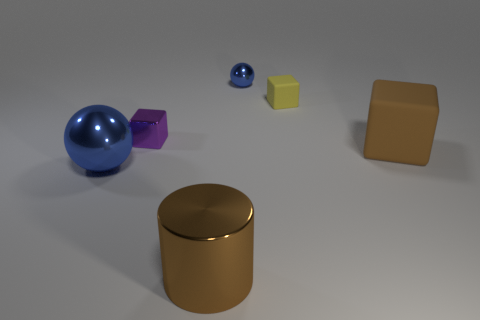Are there an equal number of brown matte blocks that are behind the brown metallic thing and blue balls?
Your response must be concise. No. How many objects are either brown objects that are to the left of the small shiny sphere or small brown shiny cylinders?
Your answer should be compact. 1. The large thing that is to the right of the small purple metal thing and to the left of the large matte object has what shape?
Keep it short and to the point. Cylinder. How many things are blocks in front of the purple object or metallic objects on the right side of the large blue metallic ball?
Give a very brief answer. 4. What number of other objects are there of the same size as the brown metal thing?
Your answer should be very brief. 2. There is a rubber block left of the big matte cube; is it the same color as the big sphere?
Offer a terse response. No. How big is the object that is to the right of the large cylinder and left of the small yellow thing?
Offer a very short reply. Small. How many big objects are yellow matte cylinders or blue things?
Provide a succinct answer. 1. The brown thing that is on the left side of the large brown matte block has what shape?
Offer a very short reply. Cylinder. How many tiny purple shiny cubes are there?
Your answer should be very brief. 1. 